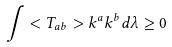<formula> <loc_0><loc_0><loc_500><loc_500>\int < T _ { a b } > k ^ { a } k ^ { b } d \lambda \geq 0</formula> 